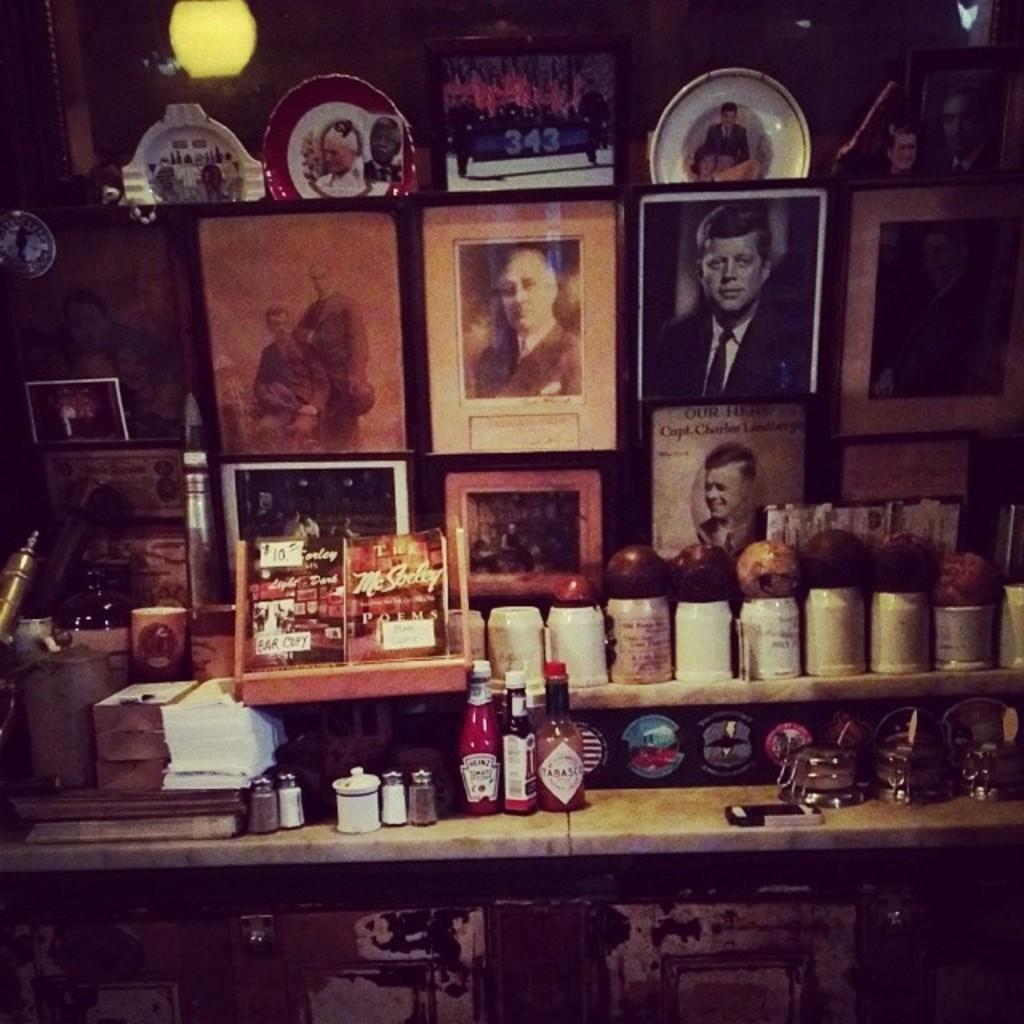What objects are present in the image that are used for displaying photos? There are photo frames in the image. What type of containers can be seen in the image? There are bottles in the image. What items in the image might be used for writing or reading? There are papers in the image. What objects are on a table in the image? There are bowls on a table in the image. What source of illumination is visible in the image? There is a light visible in the image. What is the taste of the light in the image? Lights do not have a taste, as they are not edible objects. 